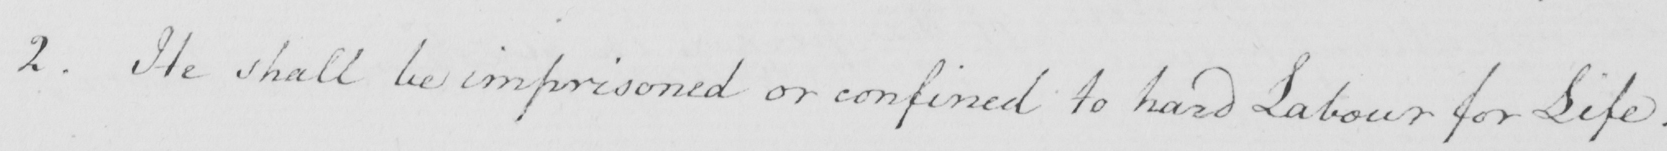What is written in this line of handwriting? 2 . He shall be imprisoned or confined to hard Labour for Life . 